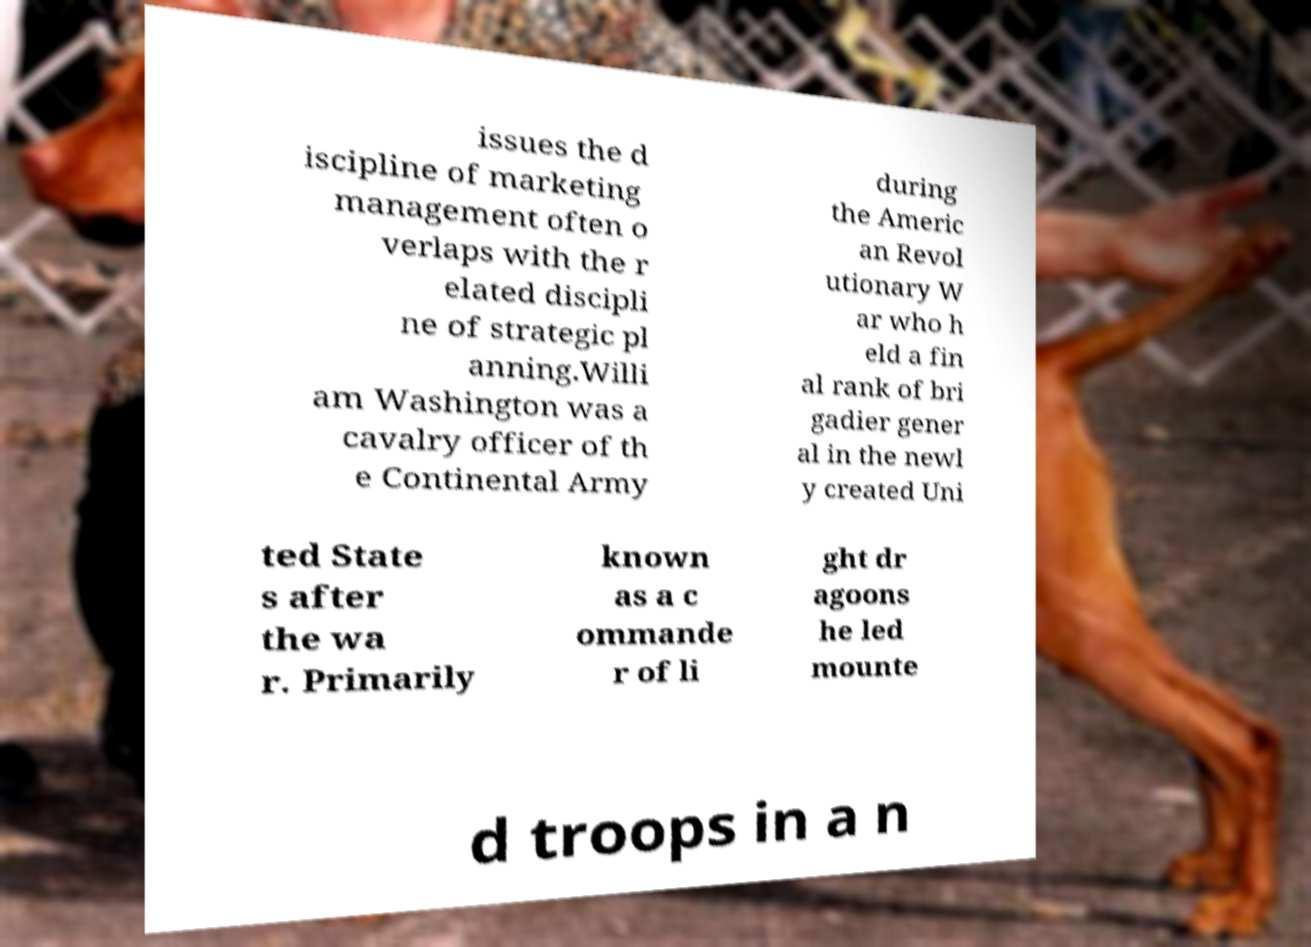Can you read and provide the text displayed in the image?This photo seems to have some interesting text. Can you extract and type it out for me? issues the d iscipline of marketing management often o verlaps with the r elated discipli ne of strategic pl anning.Willi am Washington was a cavalry officer of th e Continental Army during the Americ an Revol utionary W ar who h eld a fin al rank of bri gadier gener al in the newl y created Uni ted State s after the wa r. Primarily known as a c ommande r of li ght dr agoons he led mounte d troops in a n 